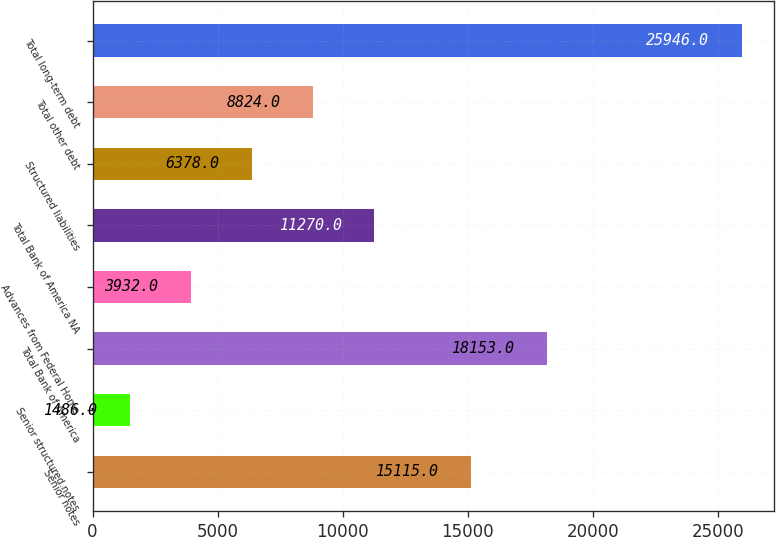Convert chart. <chart><loc_0><loc_0><loc_500><loc_500><bar_chart><fcel>Senior notes<fcel>Senior structured notes<fcel>Total Bank of America<fcel>Advances from Federal Home<fcel>Total Bank of America NA<fcel>Structured liabilities<fcel>Total other debt<fcel>Total long-term debt<nl><fcel>15115<fcel>1486<fcel>18153<fcel>3932<fcel>11270<fcel>6378<fcel>8824<fcel>25946<nl></chart> 